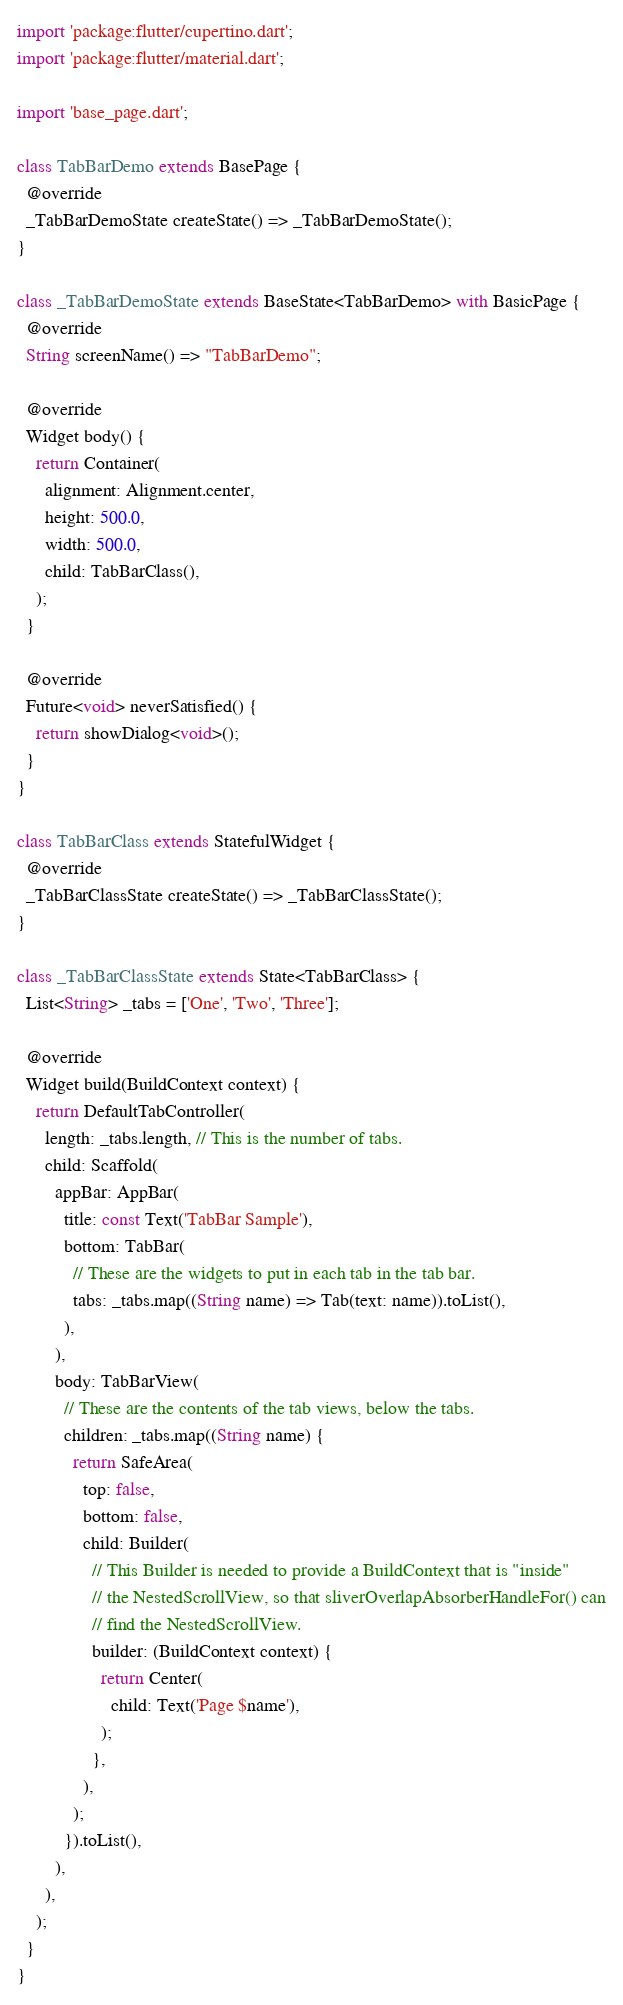<code> <loc_0><loc_0><loc_500><loc_500><_Dart_>import 'package:flutter/cupertino.dart';
import 'package:flutter/material.dart';

import 'base_page.dart';

class TabBarDemo extends BasePage {
  @override
  _TabBarDemoState createState() => _TabBarDemoState();
}

class _TabBarDemoState extends BaseState<TabBarDemo> with BasicPage {
  @override
  String screenName() => "TabBarDemo";

  @override
  Widget body() {
    return Container(
      alignment: Alignment.center,
      height: 500.0,
      width: 500.0,
      child: TabBarClass(),
    );
  }

  @override
  Future<void> neverSatisfied() {
    return showDialog<void>();
  }
}

class TabBarClass extends StatefulWidget {
  @override
  _TabBarClassState createState() => _TabBarClassState();
}

class _TabBarClassState extends State<TabBarClass> {
  List<String> _tabs = ['One', 'Two', 'Three'];

  @override
  Widget build(BuildContext context) {
    return DefaultTabController(
      length: _tabs.length, // This is the number of tabs.
      child: Scaffold(
        appBar: AppBar(
          title: const Text('TabBar Sample'),
          bottom: TabBar(
            // These are the widgets to put in each tab in the tab bar.
            tabs: _tabs.map((String name) => Tab(text: name)).toList(),
          ),
        ),
        body: TabBarView(
          // These are the contents of the tab views, below the tabs.
          children: _tabs.map((String name) {
            return SafeArea(
              top: false,
              bottom: false,
              child: Builder(
                // This Builder is needed to provide a BuildContext that is "inside"
                // the NestedScrollView, so that sliverOverlapAbsorberHandleFor() can
                // find the NestedScrollView.
                builder: (BuildContext context) {
                  return Center(
                    child: Text('Page $name'),
                  );
                },
              ),
            );
          }).toList(),
        ),
      ),
    );
  }
}
</code> 